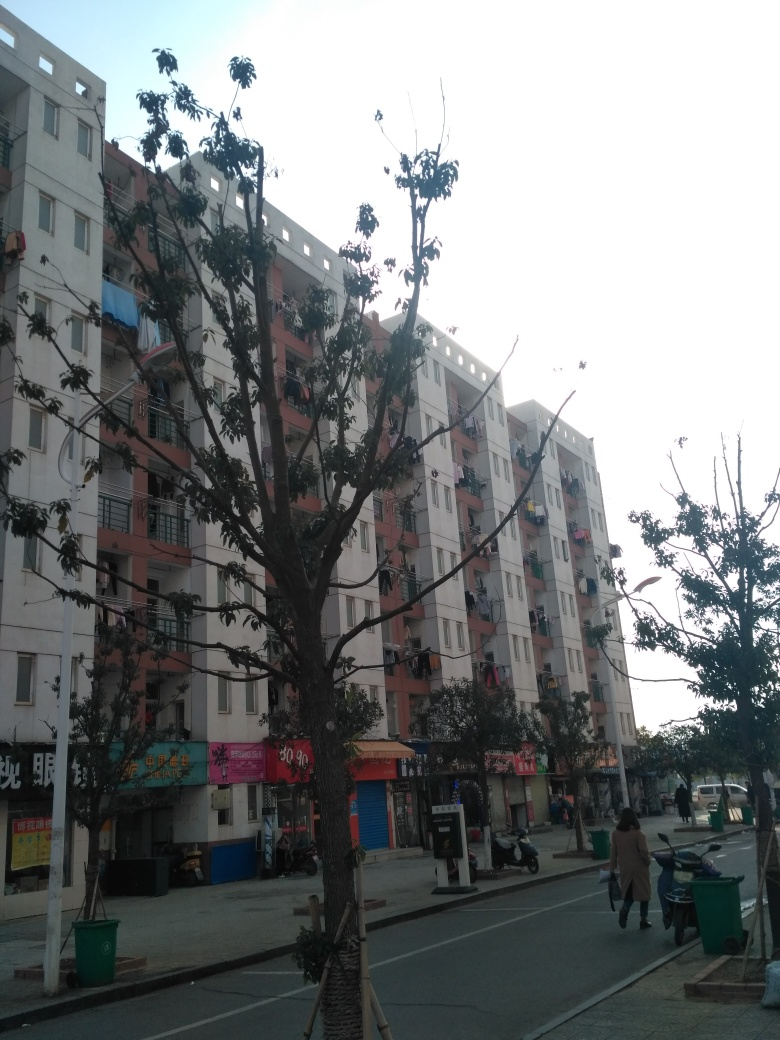What does the presence of green bins on the sidewalk indicate about this urban space? The green bins on the sidewalk suggest an organized effort to manage waste, likely part of a public sanitation system. It indicates that there is an infrastructure in place to maintain cleanliness in the neighborhood and that there is an expectation for residents and passersby to use these facilities to properly dispose of their trash. 